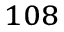<formula> <loc_0><loc_0><loc_500><loc_500>^ { 1 0 8 }</formula> 